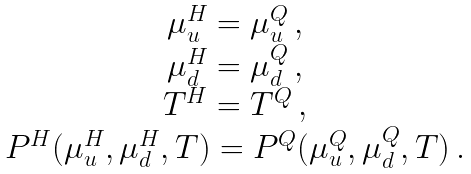<formula> <loc_0><loc_0><loc_500><loc_500>\begin{array} { c } \mu ^ { H } _ { u } = \mu ^ { Q } _ { u } \, , \\ \mu ^ { H } _ { d } = \mu ^ { Q } _ { d } \, , \\ T ^ { H } = T ^ { Q } \, , \\ P ^ { H } ( \mu ^ { H } _ { u } , \mu ^ { H } _ { d } , T ) = P ^ { Q } ( \mu ^ { Q } _ { u } , \mu ^ { Q } _ { d } , T ) \, . \\ \end{array}</formula> 